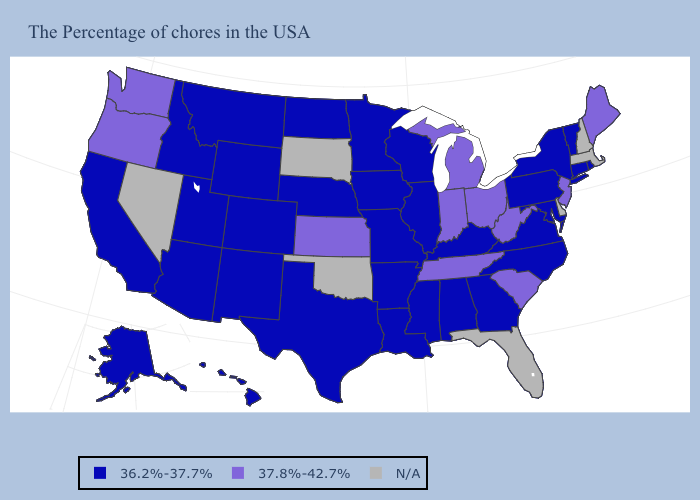Among the states that border Vermont , which have the highest value?
Keep it brief. New York. What is the value of Kansas?
Write a very short answer. 37.8%-42.7%. Does the map have missing data?
Write a very short answer. Yes. Is the legend a continuous bar?
Give a very brief answer. No. What is the value of Connecticut?
Give a very brief answer. 36.2%-37.7%. Does Alaska have the lowest value in the West?
Answer briefly. Yes. Name the states that have a value in the range 36.2%-37.7%?
Concise answer only. Rhode Island, Vermont, Connecticut, New York, Maryland, Pennsylvania, Virginia, North Carolina, Georgia, Kentucky, Alabama, Wisconsin, Illinois, Mississippi, Louisiana, Missouri, Arkansas, Minnesota, Iowa, Nebraska, Texas, North Dakota, Wyoming, Colorado, New Mexico, Utah, Montana, Arizona, Idaho, California, Alaska, Hawaii. What is the value of Oregon?
Keep it brief. 37.8%-42.7%. Name the states that have a value in the range 37.8%-42.7%?
Quick response, please. Maine, New Jersey, South Carolina, West Virginia, Ohio, Michigan, Indiana, Tennessee, Kansas, Washington, Oregon. Name the states that have a value in the range N/A?
Short answer required. Massachusetts, New Hampshire, Delaware, Florida, Oklahoma, South Dakota, Nevada. Which states hav the highest value in the Northeast?
Give a very brief answer. Maine, New Jersey. 